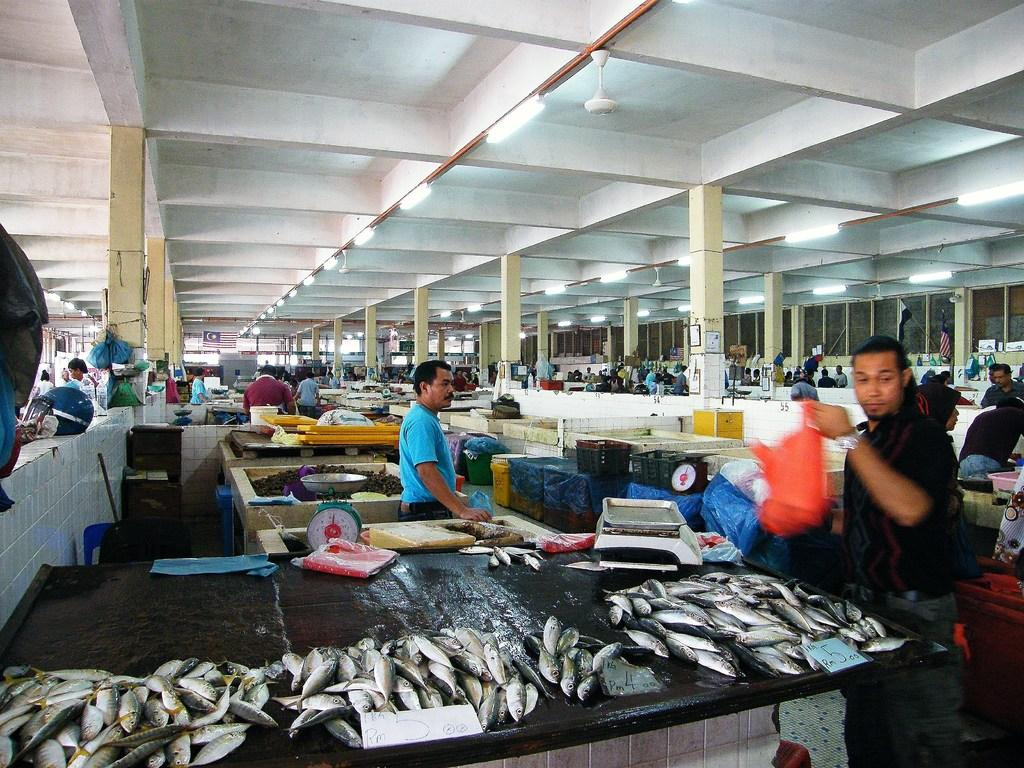What type of animals can be seen in the image? There are fishes in the image. What type of furniture or surface is present in the image? There are countertops in the image. What device is used for measuring weight in the image? There is a weighing machine in the image. How many people are present in the image? There are persons in the image. What architectural feature is present in the image? There are pillars in the image. What type of lighting is present in the image? There are tube lights in the image. What type of appliance is present in the image for air circulation? There are fans in the image. Can you see the moon in the image? No, the moon is not present in the image. What type of fish is being operated on in the image? There is no fish being operated on in the image, as it features fishes in an aquatic setting and not a medical procedure. 